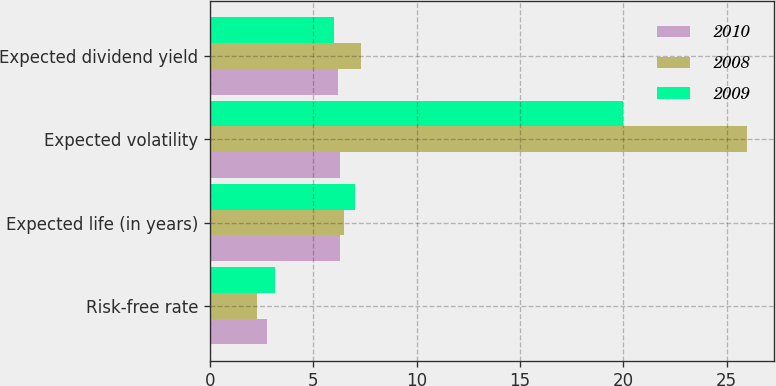<chart> <loc_0><loc_0><loc_500><loc_500><stacked_bar_chart><ecel><fcel>Risk-free rate<fcel>Expected life (in years)<fcel>Expected volatility<fcel>Expected dividend yield<nl><fcel>2010<fcel>2.77<fcel>6.3<fcel>6.3<fcel>6.2<nl><fcel>2008<fcel>2.27<fcel>6.5<fcel>26<fcel>7.3<nl><fcel>2009<fcel>3.15<fcel>7<fcel>20<fcel>6<nl></chart> 